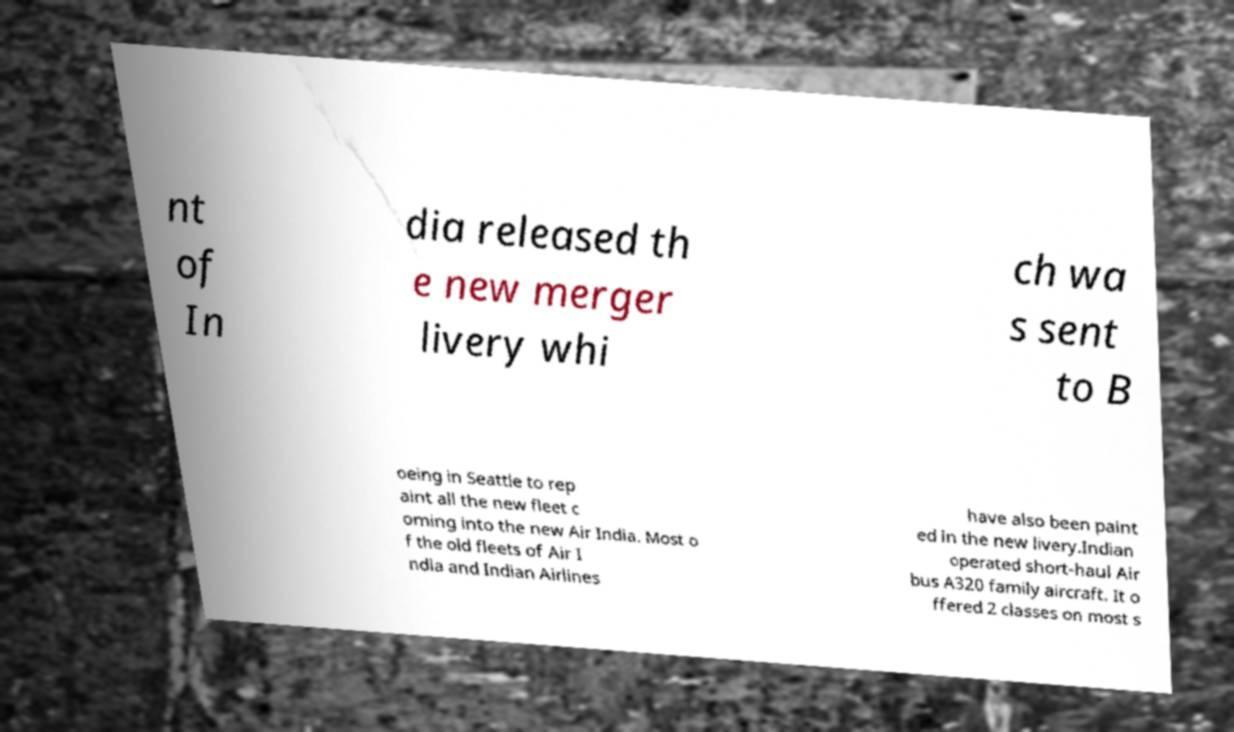Please read and relay the text visible in this image. What does it say? nt of In dia released th e new merger livery whi ch wa s sent to B oeing in Seattle to rep aint all the new fleet c oming into the new Air India. Most o f the old fleets of Air I ndia and Indian Airlines have also been paint ed in the new livery.Indian operated short-haul Air bus A320 family aircraft. It o ffered 2 classes on most s 